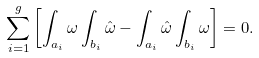<formula> <loc_0><loc_0><loc_500><loc_500>\sum _ { i = 1 } ^ { g } \left [ \int _ { { a } _ { i } } \omega \int _ { b _ { i } } \hat { \omega } - \int _ { a _ { i } } \hat { \omega } \int _ { { b } _ { i } } \omega \right ] = 0 .</formula> 